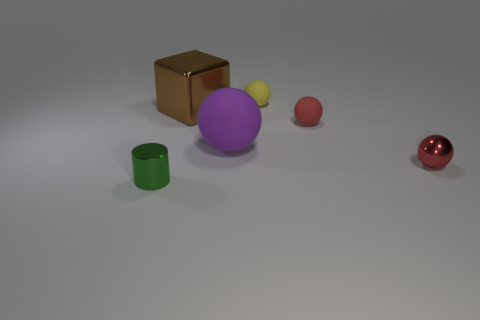Add 3 big metal blocks. How many objects exist? 9 Subtract all balls. How many objects are left? 2 Subtract all tiny blue metal blocks. Subtract all brown blocks. How many objects are left? 5 Add 3 small green metal things. How many small green metal things are left? 4 Add 4 big matte spheres. How many big matte spheres exist? 5 Subtract 1 green cylinders. How many objects are left? 5 